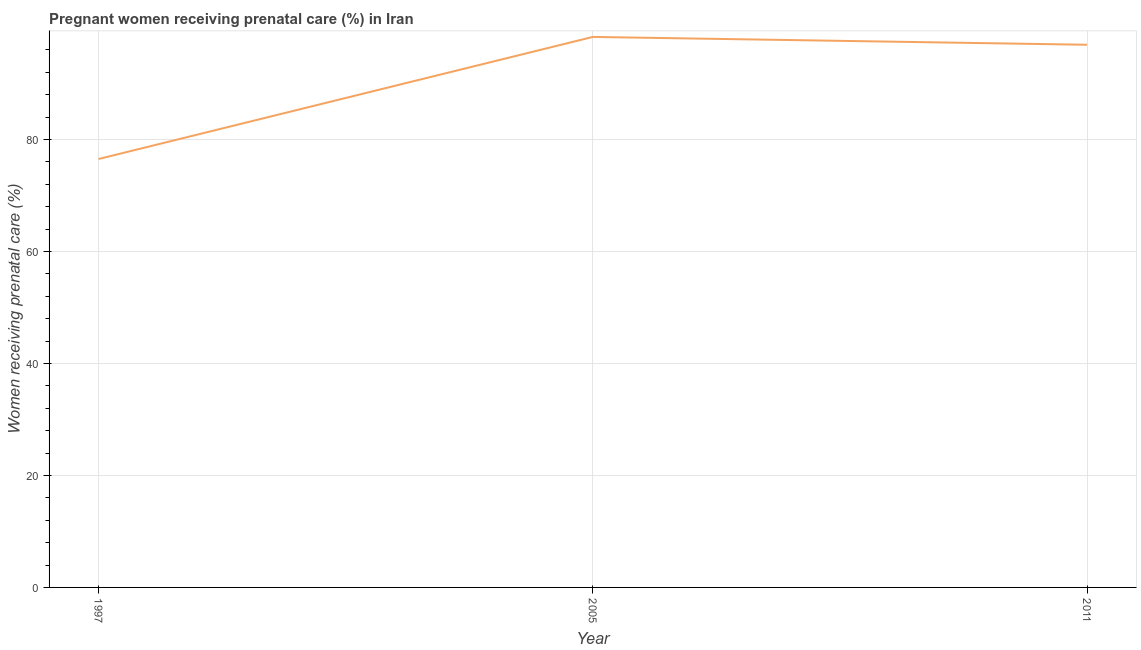What is the percentage of pregnant women receiving prenatal care in 2005?
Your response must be concise. 98.3. Across all years, what is the maximum percentage of pregnant women receiving prenatal care?
Give a very brief answer. 98.3. Across all years, what is the minimum percentage of pregnant women receiving prenatal care?
Make the answer very short. 76.5. In which year was the percentage of pregnant women receiving prenatal care minimum?
Keep it short and to the point. 1997. What is the sum of the percentage of pregnant women receiving prenatal care?
Make the answer very short. 271.7. What is the difference between the percentage of pregnant women receiving prenatal care in 1997 and 2005?
Keep it short and to the point. -21.8. What is the average percentage of pregnant women receiving prenatal care per year?
Give a very brief answer. 90.57. What is the median percentage of pregnant women receiving prenatal care?
Provide a short and direct response. 96.9. What is the ratio of the percentage of pregnant women receiving prenatal care in 1997 to that in 2011?
Your answer should be very brief. 0.79. Is the difference between the percentage of pregnant women receiving prenatal care in 1997 and 2005 greater than the difference between any two years?
Provide a succinct answer. Yes. What is the difference between the highest and the second highest percentage of pregnant women receiving prenatal care?
Offer a terse response. 1.4. What is the difference between the highest and the lowest percentage of pregnant women receiving prenatal care?
Your answer should be compact. 21.8. In how many years, is the percentage of pregnant women receiving prenatal care greater than the average percentage of pregnant women receiving prenatal care taken over all years?
Ensure brevity in your answer.  2. Does the percentage of pregnant women receiving prenatal care monotonically increase over the years?
Offer a very short reply. No. What is the difference between two consecutive major ticks on the Y-axis?
Offer a terse response. 20. Does the graph contain any zero values?
Make the answer very short. No. Does the graph contain grids?
Your answer should be compact. Yes. What is the title of the graph?
Offer a very short reply. Pregnant women receiving prenatal care (%) in Iran. What is the label or title of the X-axis?
Keep it short and to the point. Year. What is the label or title of the Y-axis?
Offer a very short reply. Women receiving prenatal care (%). What is the Women receiving prenatal care (%) in 1997?
Provide a short and direct response. 76.5. What is the Women receiving prenatal care (%) of 2005?
Your answer should be very brief. 98.3. What is the Women receiving prenatal care (%) of 2011?
Provide a succinct answer. 96.9. What is the difference between the Women receiving prenatal care (%) in 1997 and 2005?
Provide a succinct answer. -21.8. What is the difference between the Women receiving prenatal care (%) in 1997 and 2011?
Offer a very short reply. -20.4. What is the ratio of the Women receiving prenatal care (%) in 1997 to that in 2005?
Make the answer very short. 0.78. What is the ratio of the Women receiving prenatal care (%) in 1997 to that in 2011?
Your response must be concise. 0.79. What is the ratio of the Women receiving prenatal care (%) in 2005 to that in 2011?
Keep it short and to the point. 1.01. 